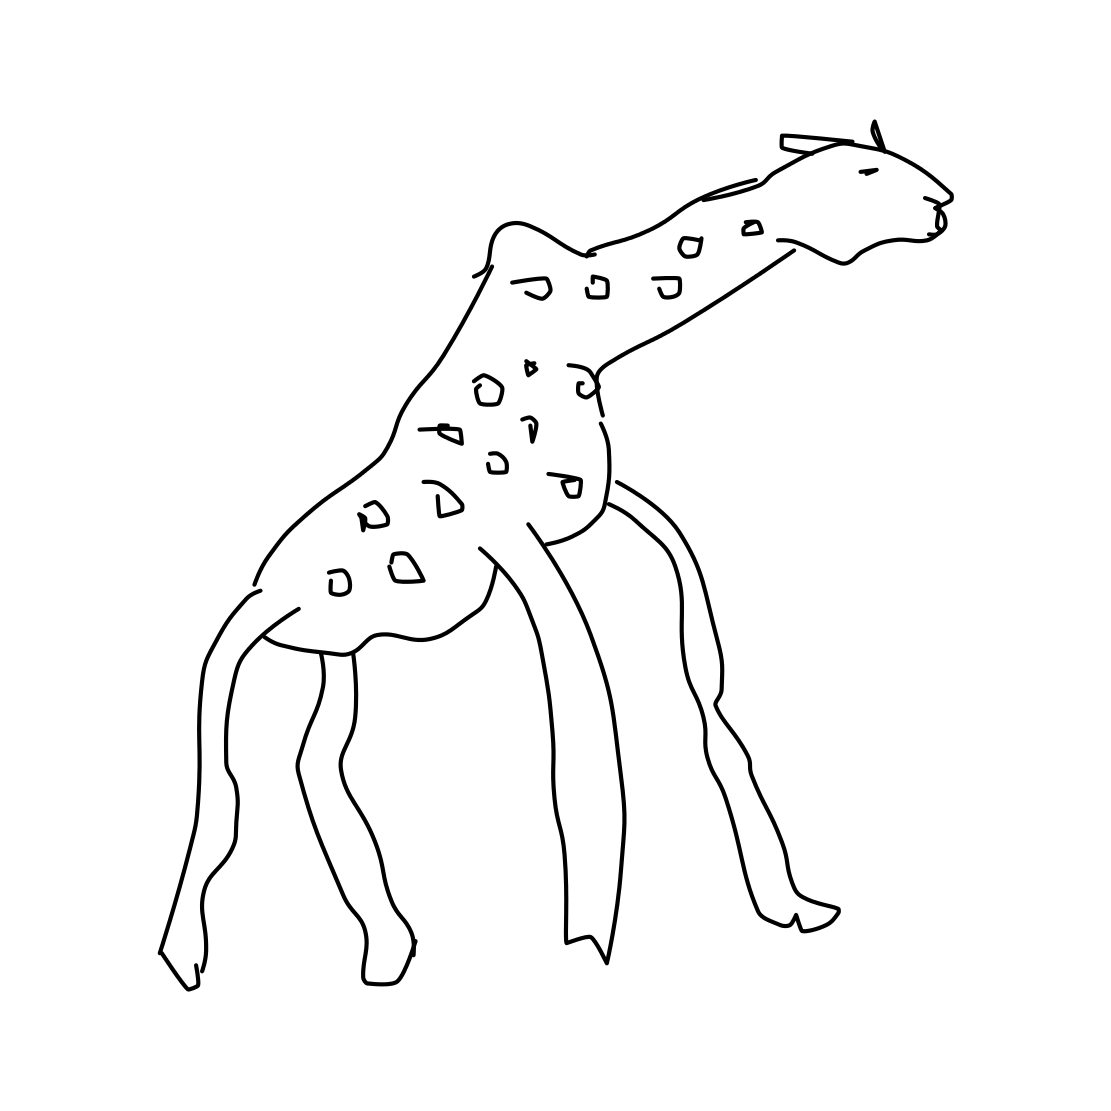Is there anything unusual about the giraffe’s anatomy in this drawing? This drawing does have a couple of peculiarities. The giraffe's legs appear to be quite thin and long, even for a giraffe, and the body is somewhat distorted. The neck also lacks the usual muscular look. It’s an artistic and stylized representation rather than an anatomically accurate one. 